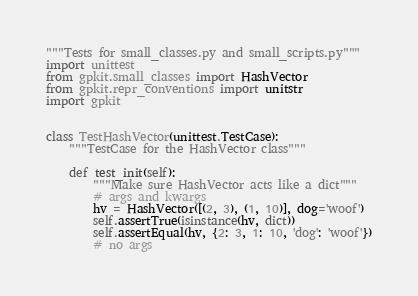Convert code to text. <code><loc_0><loc_0><loc_500><loc_500><_Python_>"""Tests for small_classes.py and small_scripts.py"""
import unittest
from gpkit.small_classes import HashVector
from gpkit.repr_conventions import unitstr
import gpkit


class TestHashVector(unittest.TestCase):
    """TestCase for the HashVector class"""

    def test_init(self):
        """Make sure HashVector acts like a dict"""
        # args and kwargs
        hv = HashVector([(2, 3), (1, 10)], dog='woof')
        self.assertTrue(isinstance(hv, dict))
        self.assertEqual(hv, {2: 3, 1: 10, 'dog': 'woof'})
        # no args</code> 